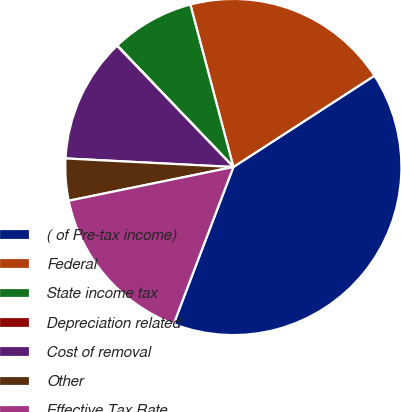<chart> <loc_0><loc_0><loc_500><loc_500><pie_chart><fcel>( of Pre-tax income)<fcel>Federal<fcel>State income tax<fcel>Depreciation related<fcel>Cost of removal<fcel>Other<fcel>Effective Tax Rate<nl><fcel>39.93%<fcel>19.98%<fcel>8.02%<fcel>0.04%<fcel>12.01%<fcel>4.03%<fcel>16.0%<nl></chart> 